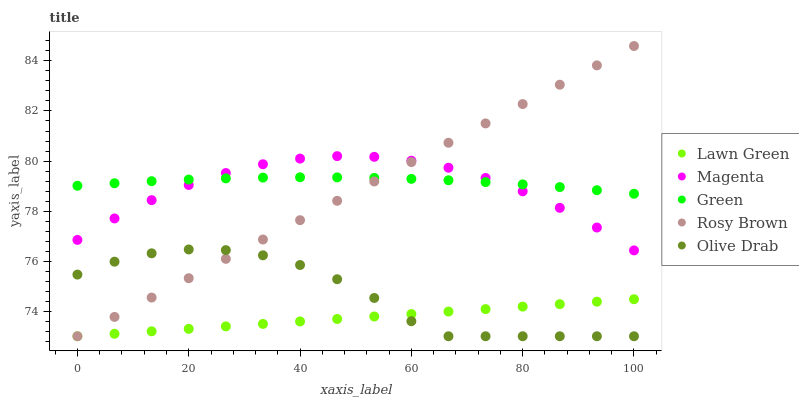Does Lawn Green have the minimum area under the curve?
Answer yes or no. Yes. Does Green have the maximum area under the curve?
Answer yes or no. Yes. Does Magenta have the minimum area under the curve?
Answer yes or no. No. Does Magenta have the maximum area under the curve?
Answer yes or no. No. Is Lawn Green the smoothest?
Answer yes or no. Yes. Is Olive Drab the roughest?
Answer yes or no. Yes. Is Magenta the smoothest?
Answer yes or no. No. Is Magenta the roughest?
Answer yes or no. No. Does Lawn Green have the lowest value?
Answer yes or no. Yes. Does Magenta have the lowest value?
Answer yes or no. No. Does Rosy Brown have the highest value?
Answer yes or no. Yes. Does Magenta have the highest value?
Answer yes or no. No. Is Lawn Green less than Magenta?
Answer yes or no. Yes. Is Green greater than Olive Drab?
Answer yes or no. Yes. Does Green intersect Magenta?
Answer yes or no. Yes. Is Green less than Magenta?
Answer yes or no. No. Is Green greater than Magenta?
Answer yes or no. No. Does Lawn Green intersect Magenta?
Answer yes or no. No. 